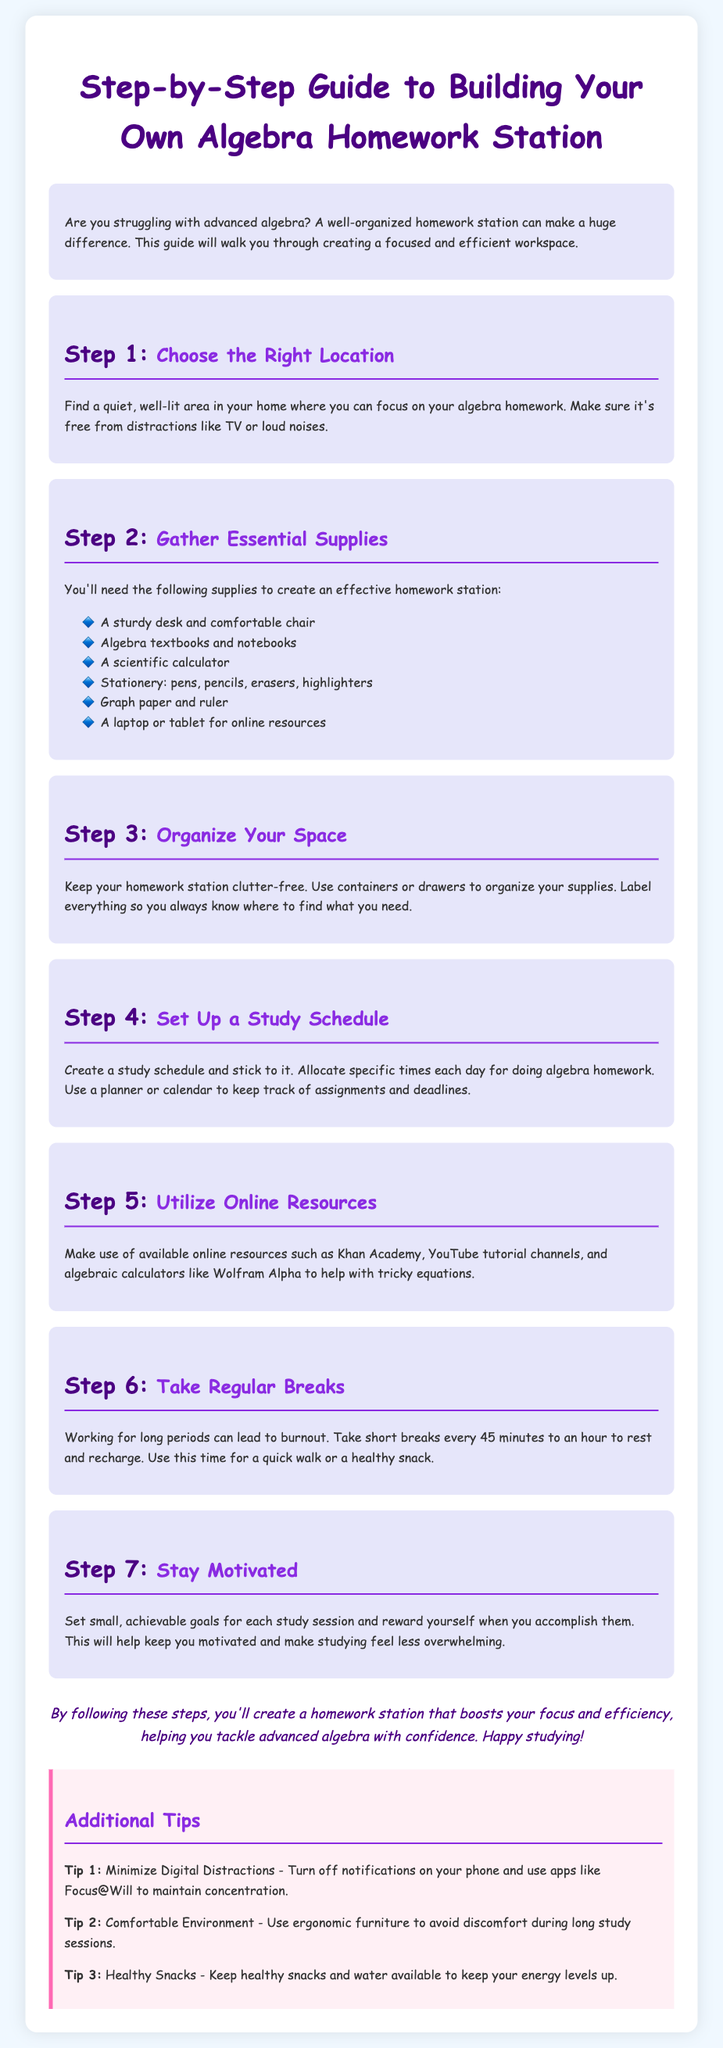What is the title of the document? The title is found in the HTML head section.
Answer: Step-by-Step Guide to Building Your Own Algebra Homework Station What is the first step in building the homework station? The first step is mentioned in the second section of the document.
Answer: Choose the Right Location How many essential supplies are listed? The number of supplies is found in the bulleted list under Step 2.
Answer: Six What color is used for the step numbers? The color of the step numbers is specified in the CSS styling within the document.
Answer: Dark purple What should you do every 45 minutes to an hour? This action is recommended in Step 6 of the document.
Answer: Take regular breaks What motivation technique is suggested in Step 7? The technique is described in the text under Step 7.
Answer: Set small, achievable goals What is included in the Additional Tips section? This section provides extra guidance relevant to the main steps.
Answer: Minimize Digital Distractions What visual element is used for list items? The document uses a specific graphic element before each list item.
Answer: A bullet point with a diamond emoji How is the conclusion formatted in the document? The conclusion is styled distinctively at the end of the document.
Answer: Italicized and centered 